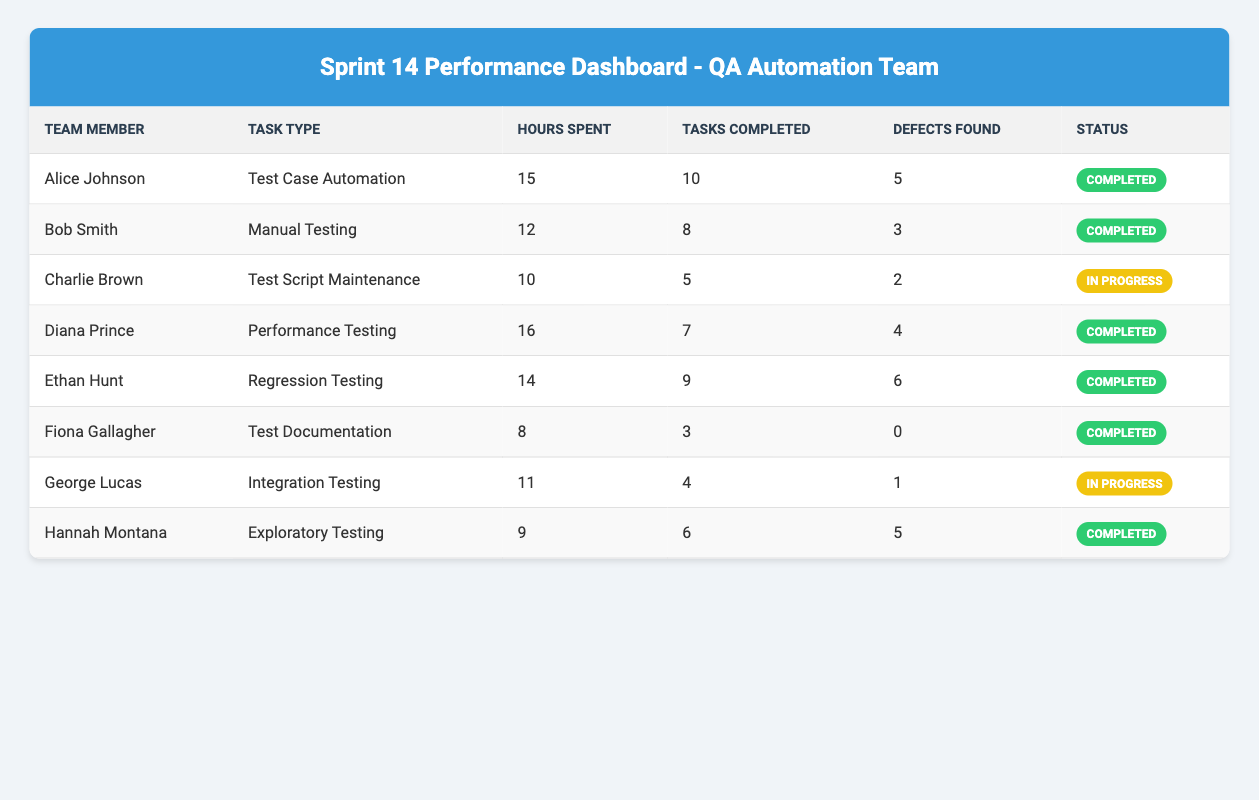What is the total number of hours spent by the team? To find the total hours, we add the hours spent by each team member: 15 + 12 + 10 + 16 + 14 + 8 + 11 + 9 = 105 hours.
Answer: 105 hours How many tasks did Alice Johnson complete? According to the table, Alice Johnson completed 10 tasks.
Answer: 10 tasks Which team member spent the least number of hours? Comparing the hours spent: Alice (15), Bob (12), Charlie (10), Diana (16), Ethan (14), Fiona (8), George (11), Hannah (9), the least is Fiona Gallagher with 8 hours.
Answer: Fiona Gallagher What is the average number of defects found by the team? Adding the defects found by each member: 5 + 3 + 2 + 4 + 6 + 0 + 1 + 5 = 26. There are 8 members, so the average is 26/8 = 3.25.
Answer: 3.25 Did anyone have an "In Progress" status? The status of each team member shows that George Lucas and Charlie Brown are "In Progress."
Answer: Yes What percentage of tasks were completed by Ethan Hunt out of his total hours spent? Ethan completed 9 tasks. The percentage of completion is calculated by (9 tasks out of total tasks completed by all which is 10 + 8 + 5 + 7 + 9 + 3 + 4 + 6 = 52 tasks) = (9/52) * 100 = 17.31%.
Answer: 17.31% Which task type had the most defects found? The task types and defects found are as follows: Test Case Automation (5), Manual Testing (3), Test Script Maintenance (2), Performance Testing (4), Regression Testing (6), Test Documentation (0), Integration Testing (1), Exploratory Testing (5). Regression Testing had the most with 6 defects.
Answer: Regression Testing What is the total number of tasks completed by the "In Progress" team members? The team members in progress are Charlie Brown (5 tasks) and George Lucas (4 tasks). Total completed = 5 + 4 = 9 tasks.
Answer: 9 tasks Who has the highest number of defects found? Comparing defects: Alice (5), Bob (3), Charlie (2), Diana (4), Ethan (6), Fiona (0), George (1), Hannah (5). Ethan Hunt has the highest defects with 6.
Answer: Ethan Hunt What is the total count of completed tasks by the QA Automation Team? Adding completed tasks: 10 (Alice) + 8 (Bob) + 0 (Fiona) + 7 (Diana) + 9 (Ethan) + 6 (Hannah) = 40 tasks.
Answer: 40 tasks 